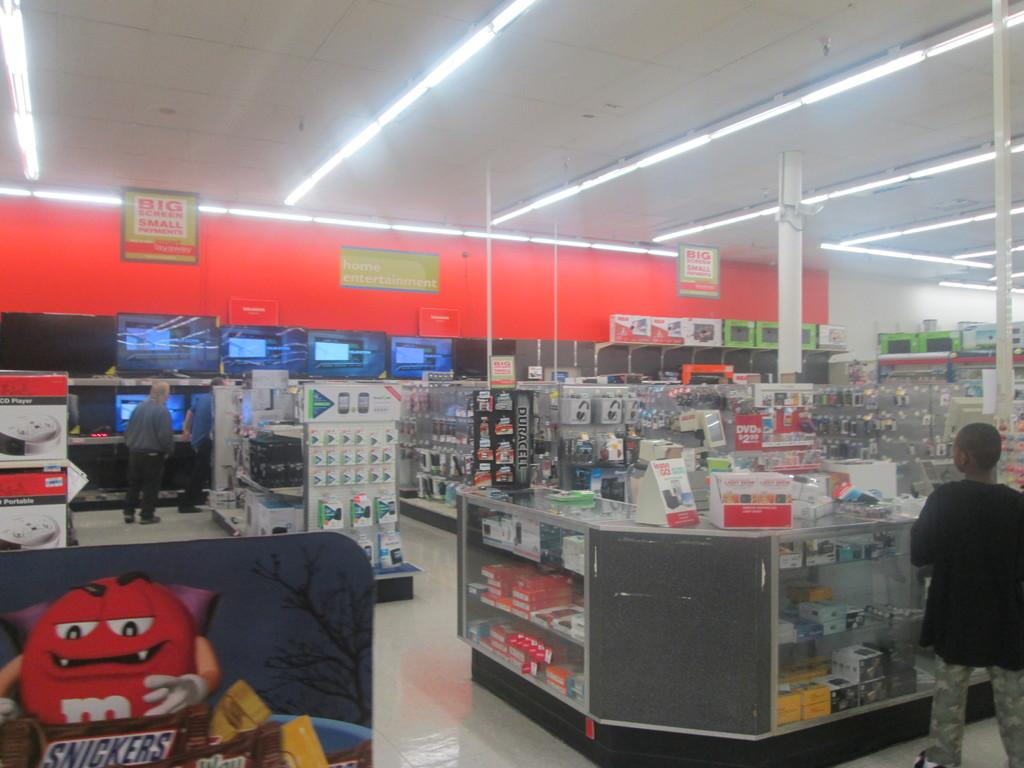Provide a one-sentence caption for the provided image. Inside a store, there is a M and M vampire about to eat a snickers bar. 